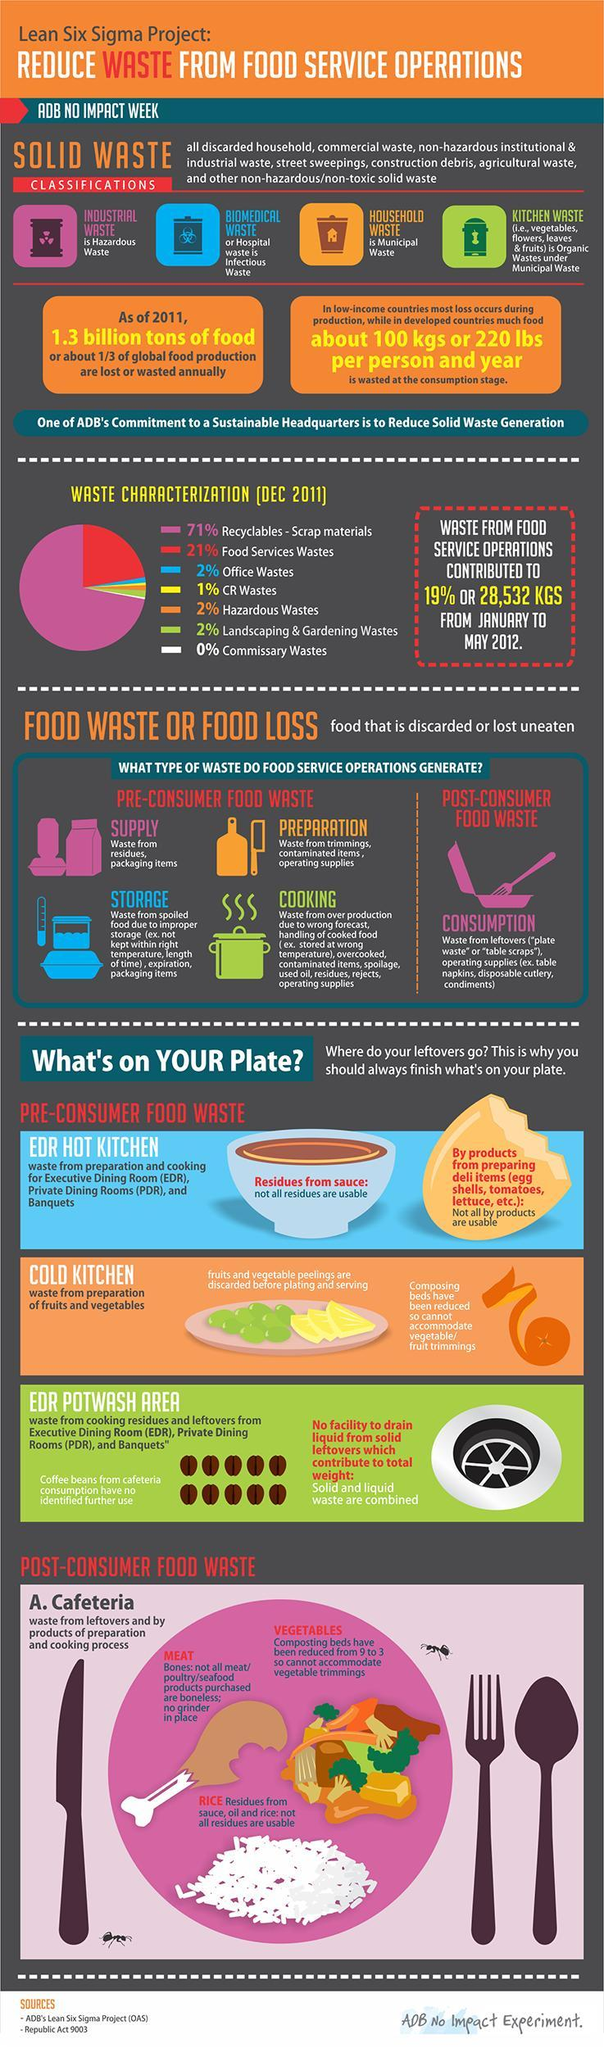Which all are the municipal wastes?
Answer the question with a short phrase. Household waste, Kitchen waste How many pre-consumer food wastes mentioned in this infographic? 4 What is the name of post-consumer food waste? Consumption Which has the highest share-recyclables-scrap materials, food services wastes? recyclables-scrap materials What is the other name for biomedical waste? Hospital waste 